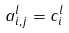<formula> <loc_0><loc_0><loc_500><loc_500>a _ { i , j } ^ { l } = c ^ { l } _ { i }</formula> 